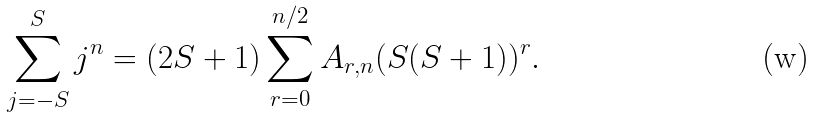Convert formula to latex. <formula><loc_0><loc_0><loc_500><loc_500>\sum _ { j = - S } ^ { S } j ^ { n } = ( 2 S + 1 ) \sum _ { r = 0 } ^ { n / 2 } A _ { r , n } ( S ( S + 1 ) ) ^ { r } .</formula> 